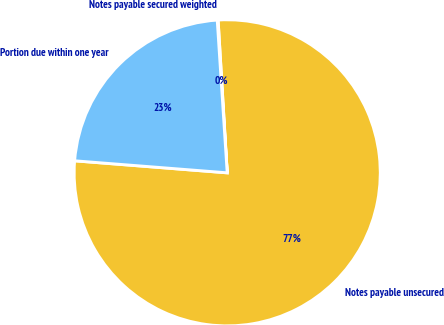Convert chart. <chart><loc_0><loc_0><loc_500><loc_500><pie_chart><fcel>Notes payable unsecured<fcel>Notes payable secured weighted<fcel>Portion due within one year<nl><fcel>77.2%<fcel>0.09%<fcel>22.71%<nl></chart> 